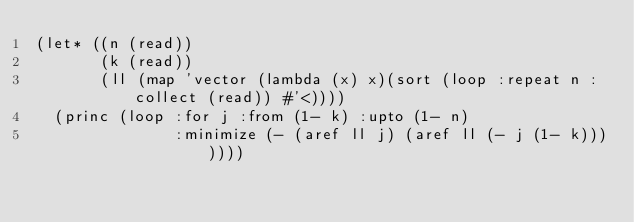Convert code to text. <code><loc_0><loc_0><loc_500><loc_500><_Lisp_>(let* ((n (read))
       (k (read))
       (ll (map 'vector (lambda (x) x)(sort (loop :repeat n :collect (read)) #'<))))
  (princ (loop :for j :from (1- k) :upto (1- n)
               :minimize (- (aref ll j) (aref ll (- j (1- k)))))))</code> 